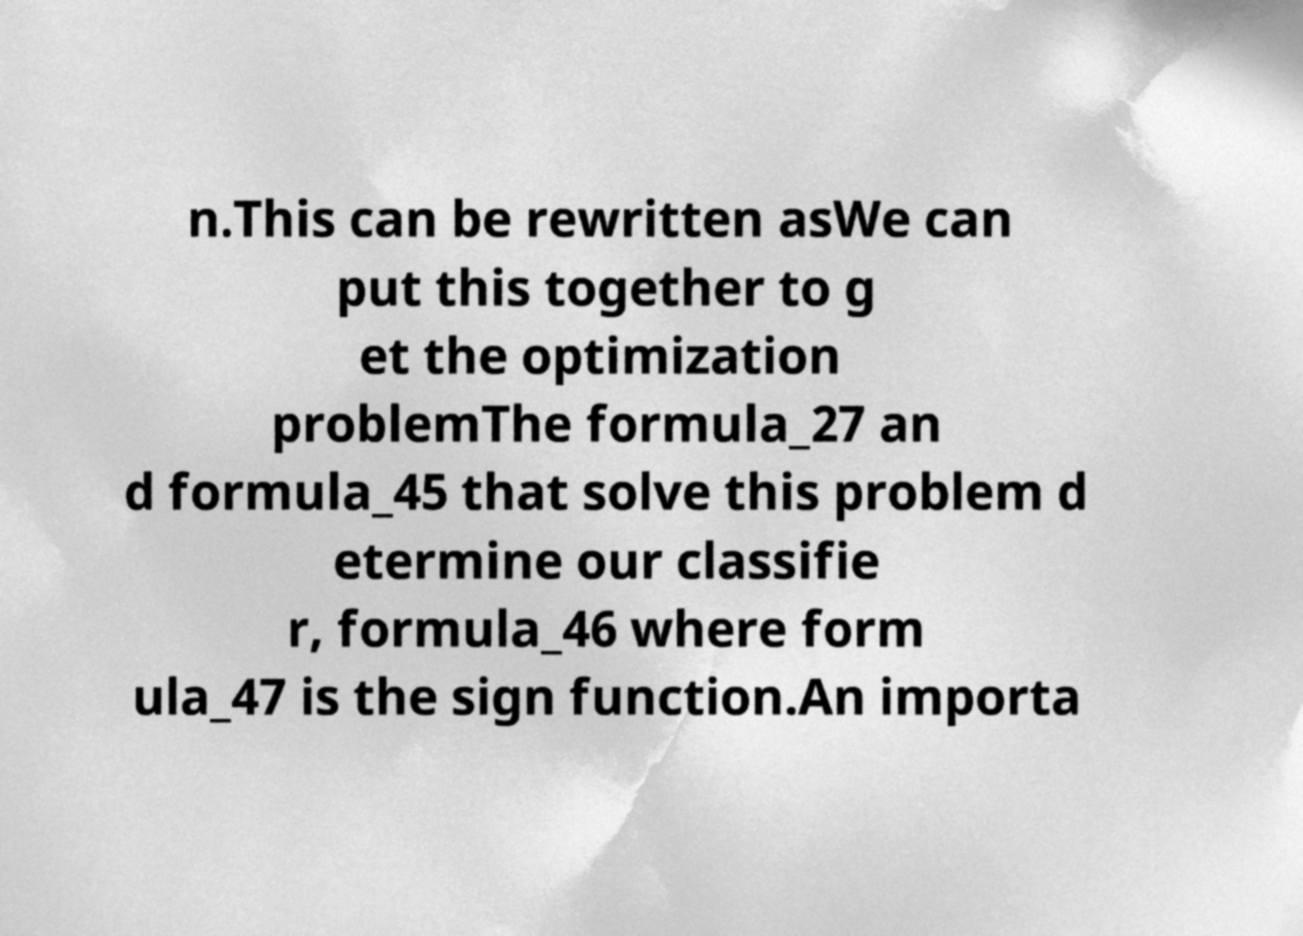Could you extract and type out the text from this image? n.This can be rewritten asWe can put this together to g et the optimization problemThe formula_27 an d formula_45 that solve this problem d etermine our classifie r, formula_46 where form ula_47 is the sign function.An importa 